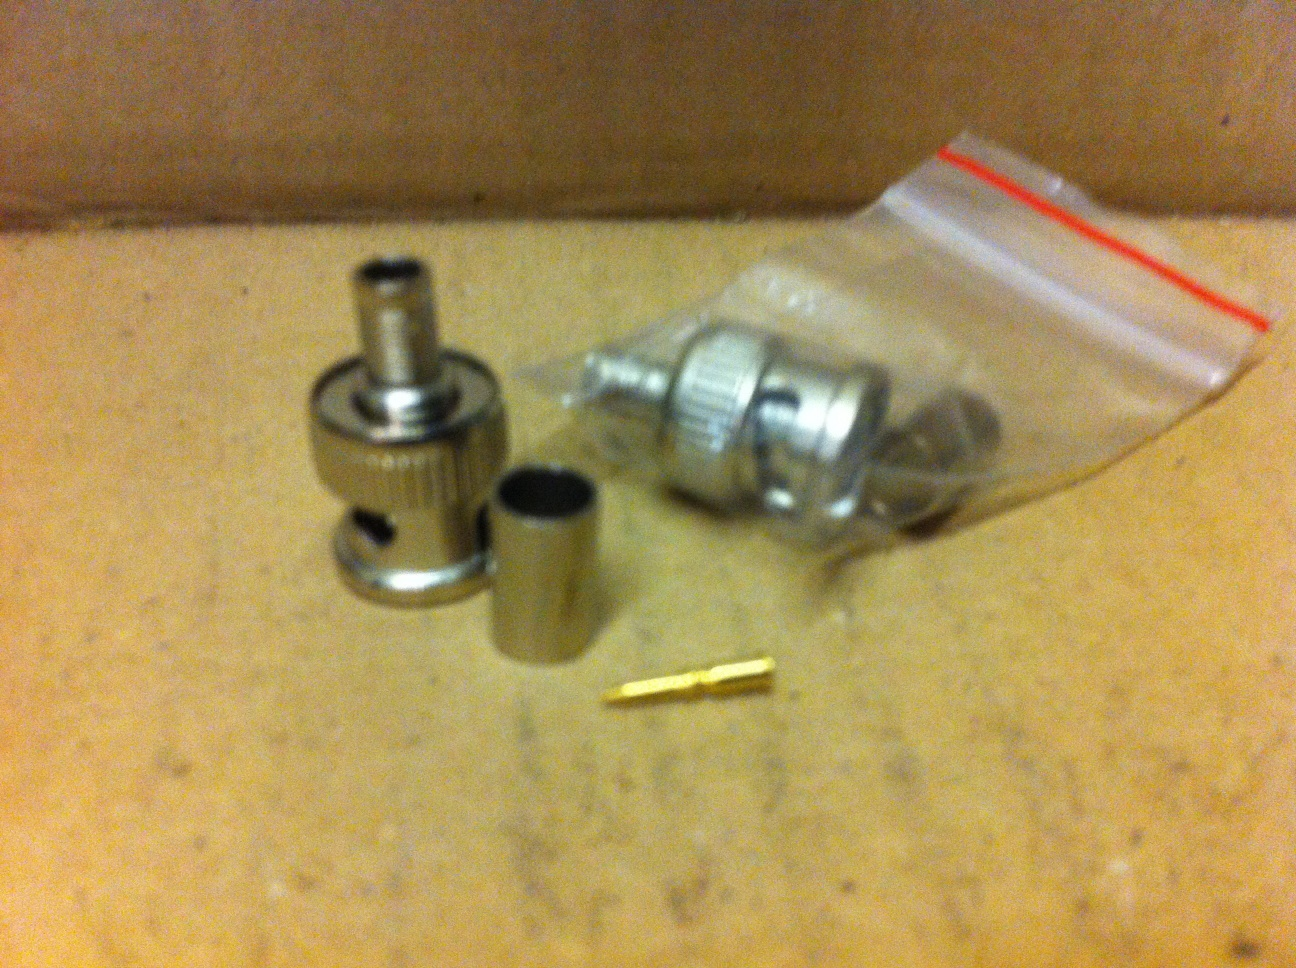Describe a realistic scenario where someone might need to use these parts. A telecom technician is setting up a new satellite dish for a residential home. To ensure a clear and uninterrupted signal, the technician needs to connect a coaxial cable from the dish to the receiver inside the house. Using these parts, the technician carefully assembles the coaxial connector, ensuring a secure and reliable connection which is crucial for maintaining a high-quality signal for the homeowner's TV and internet services. 